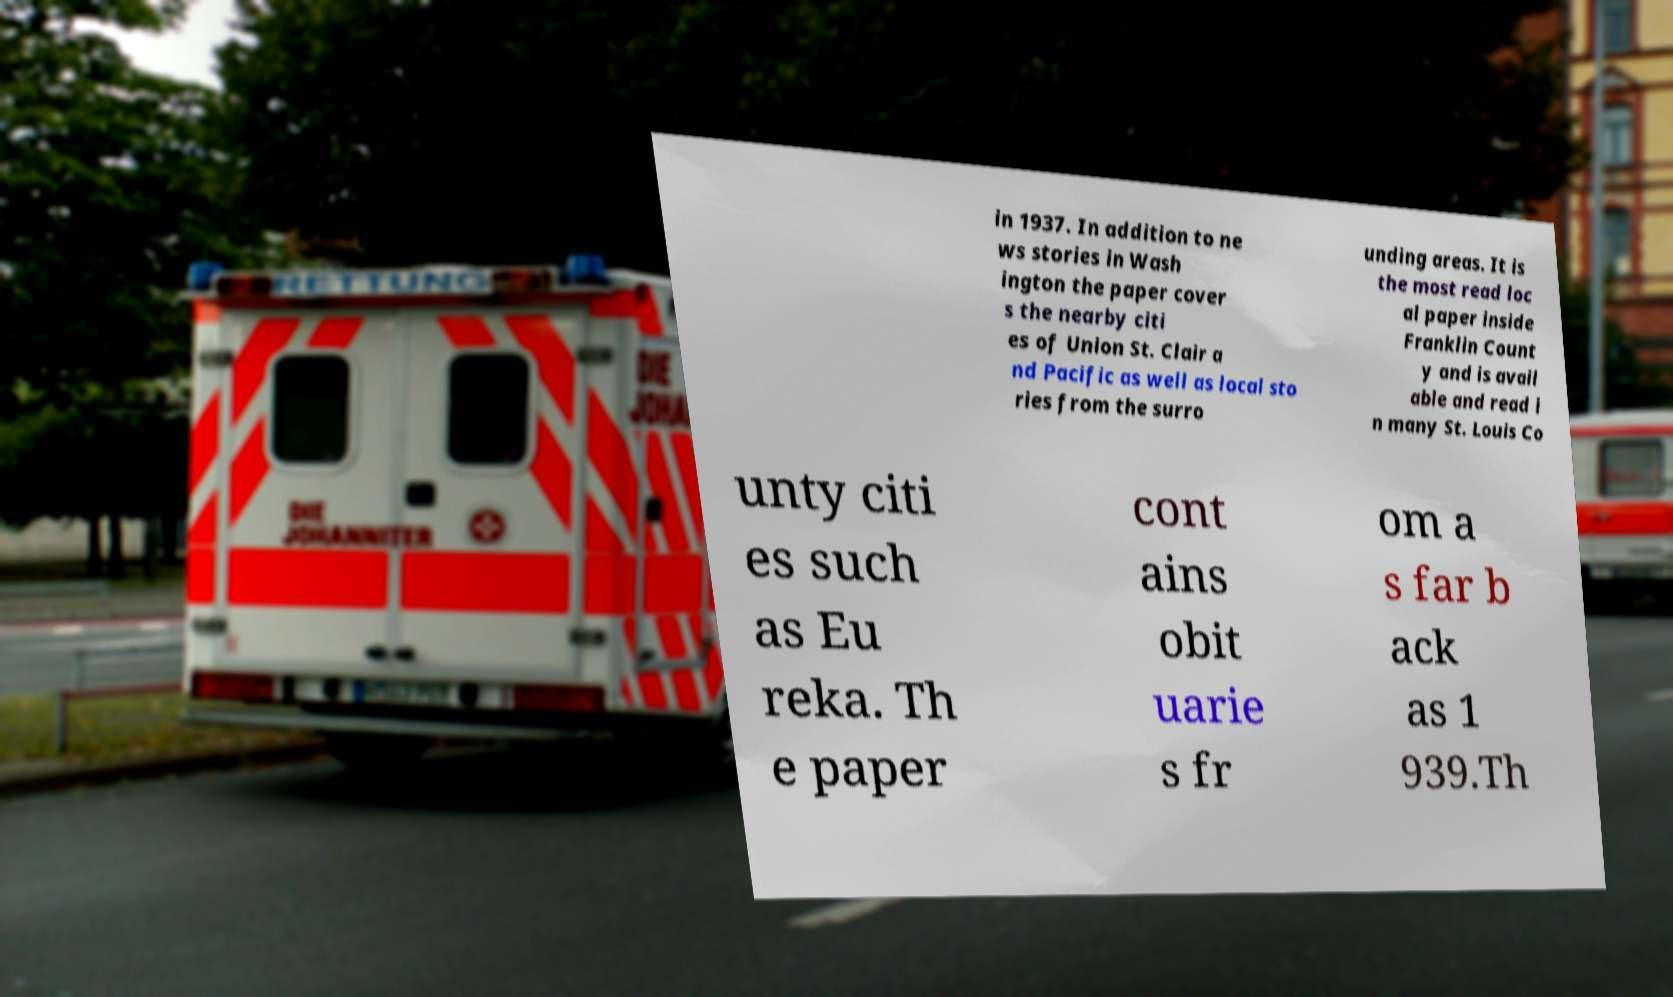Could you extract and type out the text from this image? in 1937. In addition to ne ws stories in Wash ington the paper cover s the nearby citi es of Union St. Clair a nd Pacific as well as local sto ries from the surro unding areas. It is the most read loc al paper inside Franklin Count y and is avail able and read i n many St. Louis Co unty citi es such as Eu reka. Th e paper cont ains obit uarie s fr om a s far b ack as 1 939.Th 